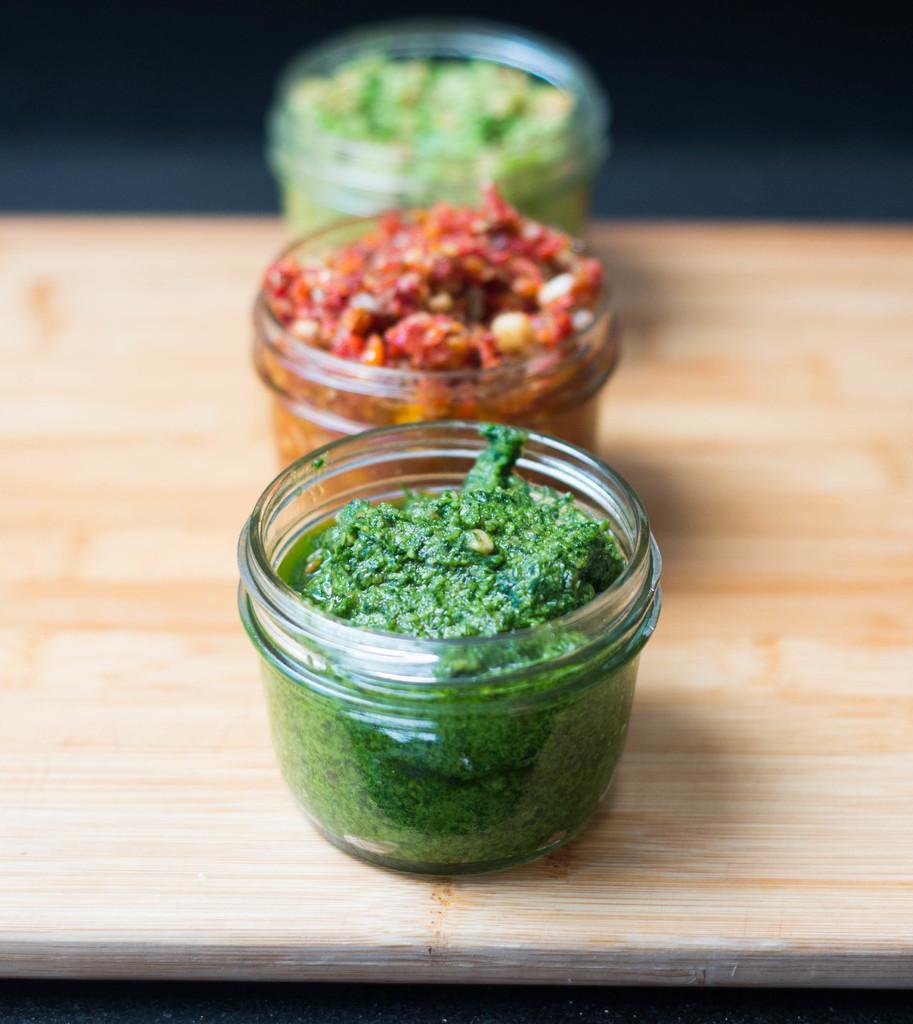Can you describe this image briefly? In this image I can see food items in three glass containers, which are placed on an object. There is a blur background. 